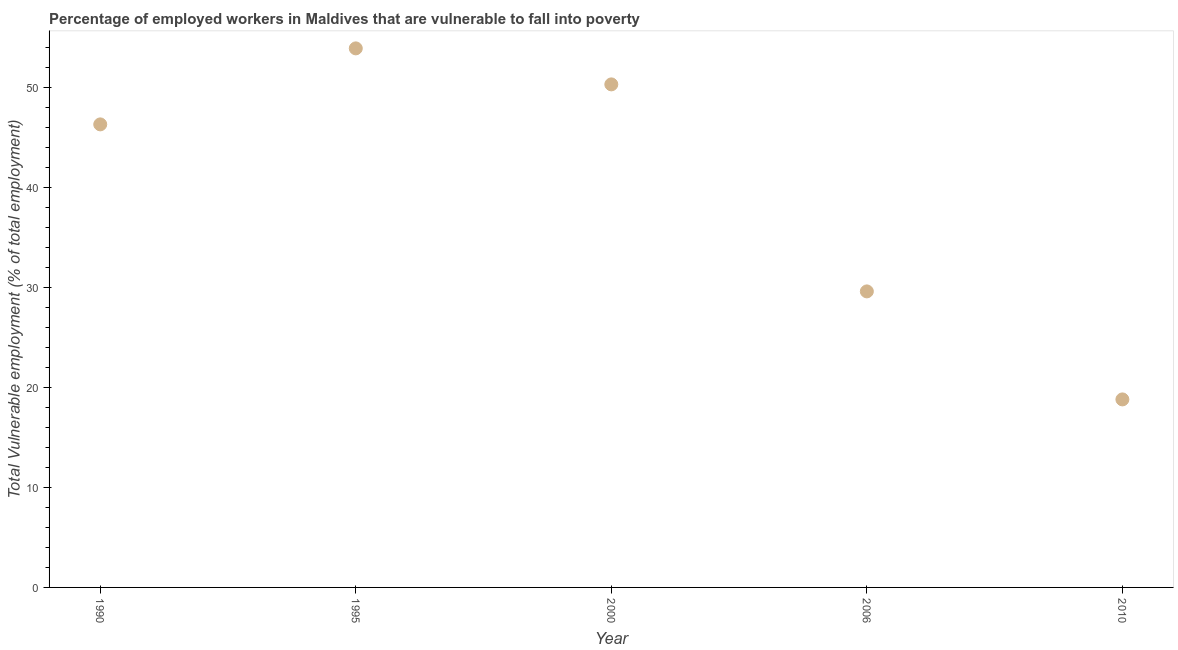What is the total vulnerable employment in 2010?
Give a very brief answer. 18.8. Across all years, what is the maximum total vulnerable employment?
Offer a terse response. 53.9. Across all years, what is the minimum total vulnerable employment?
Offer a terse response. 18.8. In which year was the total vulnerable employment maximum?
Your answer should be compact. 1995. What is the sum of the total vulnerable employment?
Give a very brief answer. 198.9. What is the difference between the total vulnerable employment in 2000 and 2006?
Give a very brief answer. 20.7. What is the average total vulnerable employment per year?
Make the answer very short. 39.78. What is the median total vulnerable employment?
Provide a short and direct response. 46.3. In how many years, is the total vulnerable employment greater than 24 %?
Keep it short and to the point. 4. What is the ratio of the total vulnerable employment in 2000 to that in 2010?
Your answer should be compact. 2.68. Is the total vulnerable employment in 1995 less than that in 2010?
Your response must be concise. No. What is the difference between the highest and the second highest total vulnerable employment?
Offer a terse response. 3.6. Is the sum of the total vulnerable employment in 1990 and 2006 greater than the maximum total vulnerable employment across all years?
Your answer should be compact. Yes. What is the difference between the highest and the lowest total vulnerable employment?
Your answer should be compact. 35.1. In how many years, is the total vulnerable employment greater than the average total vulnerable employment taken over all years?
Your answer should be very brief. 3. Does the total vulnerable employment monotonically increase over the years?
Your response must be concise. No. What is the difference between two consecutive major ticks on the Y-axis?
Your response must be concise. 10. What is the title of the graph?
Your answer should be very brief. Percentage of employed workers in Maldives that are vulnerable to fall into poverty. What is the label or title of the Y-axis?
Provide a succinct answer. Total Vulnerable employment (% of total employment). What is the Total Vulnerable employment (% of total employment) in 1990?
Offer a terse response. 46.3. What is the Total Vulnerable employment (% of total employment) in 1995?
Your answer should be compact. 53.9. What is the Total Vulnerable employment (% of total employment) in 2000?
Offer a terse response. 50.3. What is the Total Vulnerable employment (% of total employment) in 2006?
Offer a terse response. 29.6. What is the Total Vulnerable employment (% of total employment) in 2010?
Your answer should be very brief. 18.8. What is the difference between the Total Vulnerable employment (% of total employment) in 1990 and 1995?
Your answer should be compact. -7.6. What is the difference between the Total Vulnerable employment (% of total employment) in 1990 and 2010?
Your answer should be compact. 27.5. What is the difference between the Total Vulnerable employment (% of total employment) in 1995 and 2000?
Provide a short and direct response. 3.6. What is the difference between the Total Vulnerable employment (% of total employment) in 1995 and 2006?
Offer a very short reply. 24.3. What is the difference between the Total Vulnerable employment (% of total employment) in 1995 and 2010?
Provide a succinct answer. 35.1. What is the difference between the Total Vulnerable employment (% of total employment) in 2000 and 2006?
Keep it short and to the point. 20.7. What is the difference between the Total Vulnerable employment (% of total employment) in 2000 and 2010?
Offer a very short reply. 31.5. What is the ratio of the Total Vulnerable employment (% of total employment) in 1990 to that in 1995?
Give a very brief answer. 0.86. What is the ratio of the Total Vulnerable employment (% of total employment) in 1990 to that in 2000?
Provide a short and direct response. 0.92. What is the ratio of the Total Vulnerable employment (% of total employment) in 1990 to that in 2006?
Keep it short and to the point. 1.56. What is the ratio of the Total Vulnerable employment (% of total employment) in 1990 to that in 2010?
Offer a terse response. 2.46. What is the ratio of the Total Vulnerable employment (% of total employment) in 1995 to that in 2000?
Make the answer very short. 1.07. What is the ratio of the Total Vulnerable employment (% of total employment) in 1995 to that in 2006?
Offer a very short reply. 1.82. What is the ratio of the Total Vulnerable employment (% of total employment) in 1995 to that in 2010?
Your answer should be compact. 2.87. What is the ratio of the Total Vulnerable employment (% of total employment) in 2000 to that in 2006?
Offer a very short reply. 1.7. What is the ratio of the Total Vulnerable employment (% of total employment) in 2000 to that in 2010?
Your response must be concise. 2.68. What is the ratio of the Total Vulnerable employment (% of total employment) in 2006 to that in 2010?
Keep it short and to the point. 1.57. 